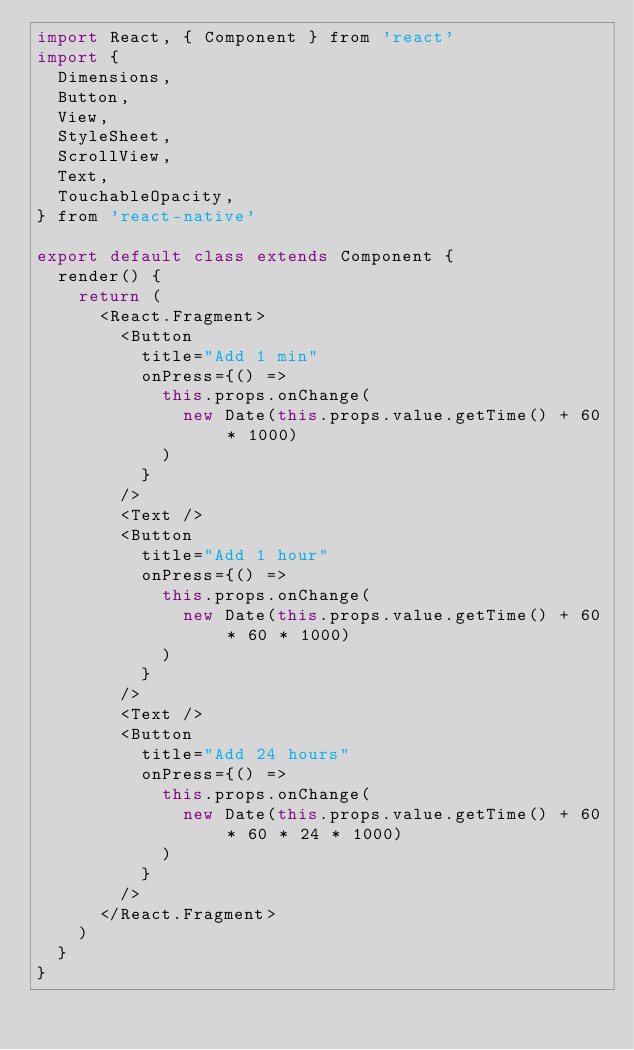<code> <loc_0><loc_0><loc_500><loc_500><_JavaScript_>import React, { Component } from 'react'
import {
  Dimensions,
  Button,
  View,
  StyleSheet,
  ScrollView,
  Text,
  TouchableOpacity,
} from 'react-native'

export default class extends Component {
  render() {
    return (
      <React.Fragment>
        <Button
          title="Add 1 min"
          onPress={() =>
            this.props.onChange(
              new Date(this.props.value.getTime() + 60 * 1000)
            )
          }
        />
        <Text />
        <Button
          title="Add 1 hour"
          onPress={() =>
            this.props.onChange(
              new Date(this.props.value.getTime() + 60 * 60 * 1000)
            )
          }
        />
        <Text />
        <Button
          title="Add 24 hours"
          onPress={() =>
            this.props.onChange(
              new Date(this.props.value.getTime() + 60 * 60 * 24 * 1000)
            )
          }
        />
      </React.Fragment>
    )
  }
}
</code> 